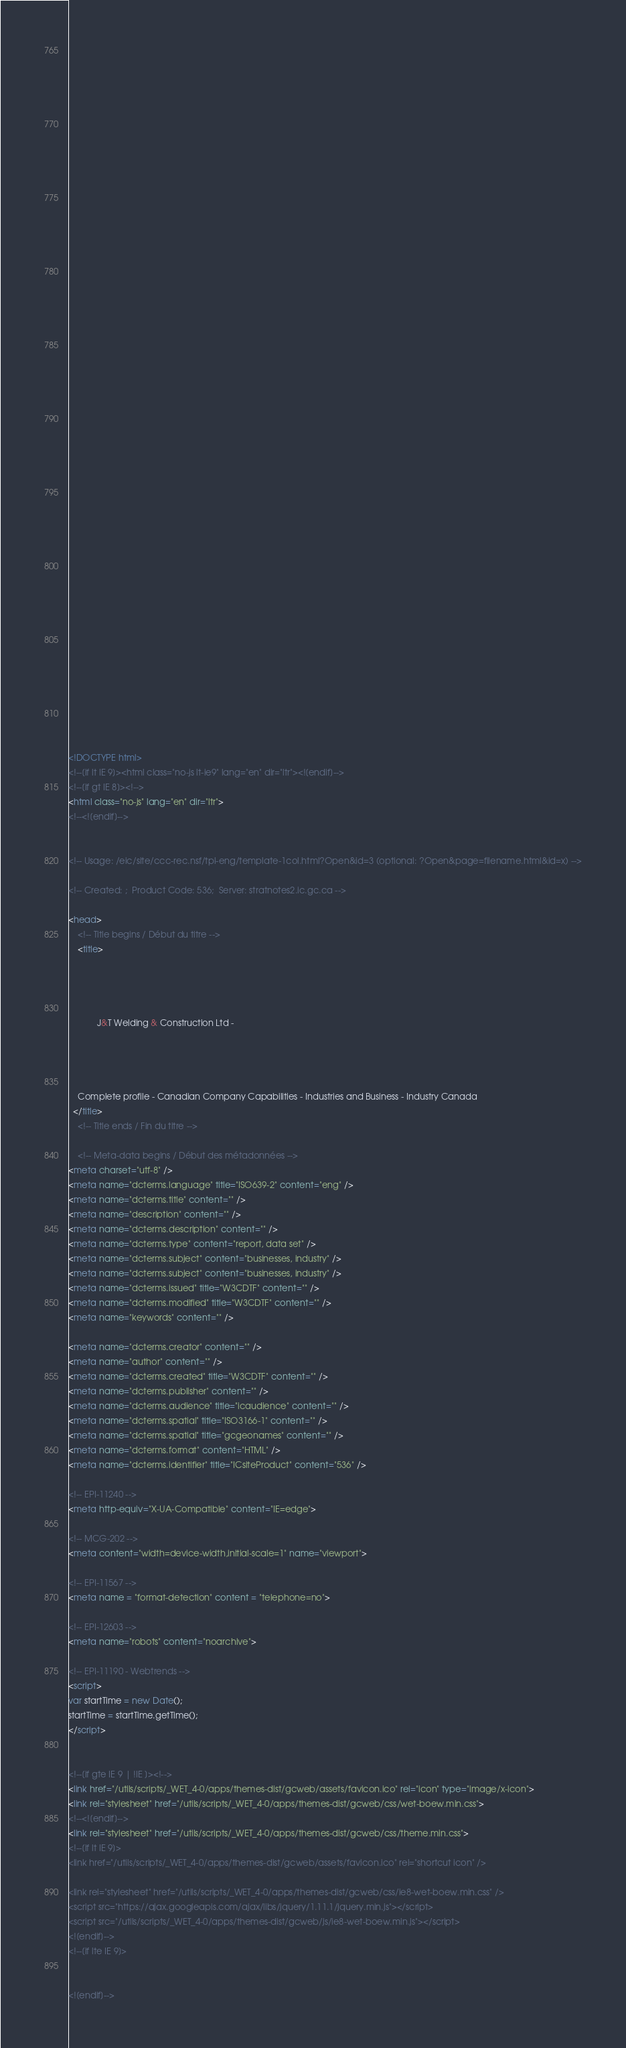<code> <loc_0><loc_0><loc_500><loc_500><_HTML_>


















	






  
  
  
  































	
	
	



<!DOCTYPE html>
<!--[if lt IE 9]><html class="no-js lt-ie9" lang="en" dir="ltr"><![endif]-->
<!--[if gt IE 8]><!-->
<html class="no-js" lang="en" dir="ltr">
<!--<![endif]-->


<!-- Usage: /eic/site/ccc-rec.nsf/tpl-eng/template-1col.html?Open&id=3 (optional: ?Open&page=filename.html&id=x) -->

<!-- Created: ;  Product Code: 536;  Server: stratnotes2.ic.gc.ca -->

<head>
	<!-- Title begins / Début du titre -->
	<title>
    
            
        
          
            J&T Welding & Construction Ltd -
          
        
      
    
    Complete profile - Canadian Company Capabilities - Industries and Business - Industry Canada
  </title>
	<!-- Title ends / Fin du titre -->
 
	<!-- Meta-data begins / Début des métadonnées -->
<meta charset="utf-8" />
<meta name="dcterms.language" title="ISO639-2" content="eng" />
<meta name="dcterms.title" content="" />
<meta name="description" content="" />
<meta name="dcterms.description" content="" />
<meta name="dcterms.type" content="report, data set" />
<meta name="dcterms.subject" content="businesses, industry" />
<meta name="dcterms.subject" content="businesses, industry" />
<meta name="dcterms.issued" title="W3CDTF" content="" />
<meta name="dcterms.modified" title="W3CDTF" content="" />
<meta name="keywords" content="" />

<meta name="dcterms.creator" content="" />
<meta name="author" content="" />
<meta name="dcterms.created" title="W3CDTF" content="" />
<meta name="dcterms.publisher" content="" />
<meta name="dcterms.audience" title="icaudience" content="" />
<meta name="dcterms.spatial" title="ISO3166-1" content="" />
<meta name="dcterms.spatial" title="gcgeonames" content="" />
<meta name="dcterms.format" content="HTML" />
<meta name="dcterms.identifier" title="ICsiteProduct" content="536" />

<!-- EPI-11240 -->
<meta http-equiv="X-UA-Compatible" content="IE=edge">

<!-- MCG-202 -->
<meta content="width=device-width,initial-scale=1" name="viewport">

<!-- EPI-11567 -->
<meta name = "format-detection" content = "telephone=no">

<!-- EPI-12603 -->
<meta name="robots" content="noarchive">

<!-- EPI-11190 - Webtrends -->
<script>
var startTime = new Date();
startTime = startTime.getTime();
</script>


<!--[if gte IE 9 | !IE ]><!-->
<link href="/utils/scripts/_WET_4-0/apps/themes-dist/gcweb/assets/favicon.ico" rel="icon" type="image/x-icon">
<link rel="stylesheet" href="/utils/scripts/_WET_4-0/apps/themes-dist/gcweb/css/wet-boew.min.css">
<!--<![endif]-->
<link rel="stylesheet" href="/utils/scripts/_WET_4-0/apps/themes-dist/gcweb/css/theme.min.css">
<!--[if lt IE 9]>
<link href="/utils/scripts/_WET_4-0/apps/themes-dist/gcweb/assets/favicon.ico" rel="shortcut icon" />

<link rel="stylesheet" href="/utils/scripts/_WET_4-0/apps/themes-dist/gcweb/css/ie8-wet-boew.min.css" />
<script src="https://ajax.googleapis.com/ajax/libs/jquery/1.11.1/jquery.min.js"></script>
<script src="/utils/scripts/_WET_4-0/apps/themes-dist/gcweb/js/ie8-wet-boew.min.js"></script>
<![endif]-->
<!--[if lte IE 9]>


<![endif]--></code> 